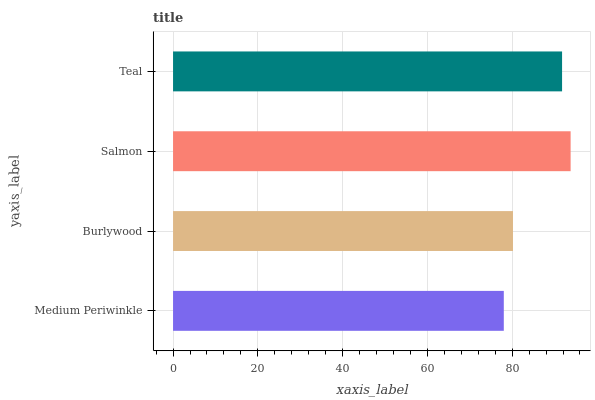Is Medium Periwinkle the minimum?
Answer yes or no. Yes. Is Salmon the maximum?
Answer yes or no. Yes. Is Burlywood the minimum?
Answer yes or no. No. Is Burlywood the maximum?
Answer yes or no. No. Is Burlywood greater than Medium Periwinkle?
Answer yes or no. Yes. Is Medium Periwinkle less than Burlywood?
Answer yes or no. Yes. Is Medium Periwinkle greater than Burlywood?
Answer yes or no. No. Is Burlywood less than Medium Periwinkle?
Answer yes or no. No. Is Teal the high median?
Answer yes or no. Yes. Is Burlywood the low median?
Answer yes or no. Yes. Is Burlywood the high median?
Answer yes or no. No. Is Salmon the low median?
Answer yes or no. No. 